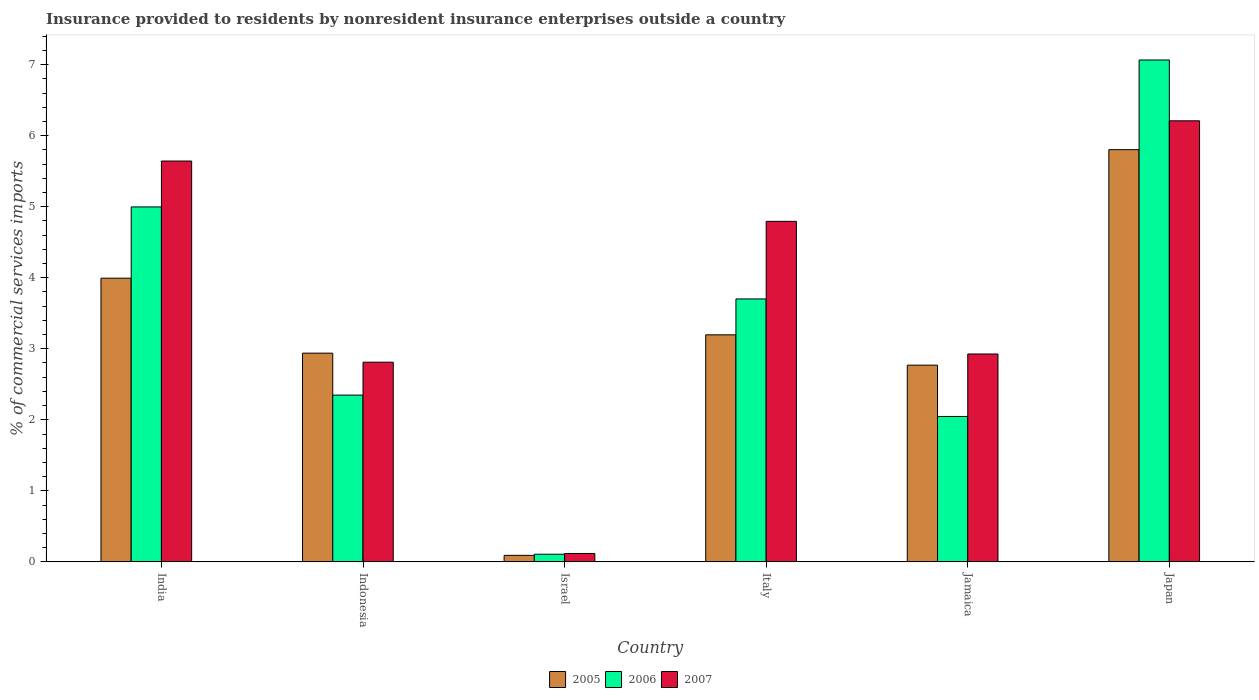How many groups of bars are there?
Keep it short and to the point. 6. How many bars are there on the 2nd tick from the right?
Provide a short and direct response. 3. What is the label of the 1st group of bars from the left?
Your answer should be very brief. India. What is the Insurance provided to residents in 2007 in Jamaica?
Offer a terse response. 2.93. Across all countries, what is the maximum Insurance provided to residents in 2005?
Keep it short and to the point. 5.8. Across all countries, what is the minimum Insurance provided to residents in 2007?
Offer a very short reply. 0.12. What is the total Insurance provided to residents in 2007 in the graph?
Your answer should be compact. 22.5. What is the difference between the Insurance provided to residents in 2007 in Indonesia and that in Jamaica?
Ensure brevity in your answer.  -0.12. What is the difference between the Insurance provided to residents in 2007 in Indonesia and the Insurance provided to residents in 2006 in India?
Offer a very short reply. -2.19. What is the average Insurance provided to residents in 2005 per country?
Provide a short and direct response. 3.13. What is the difference between the Insurance provided to residents of/in 2005 and Insurance provided to residents of/in 2006 in Italy?
Provide a succinct answer. -0.51. In how many countries, is the Insurance provided to residents in 2007 greater than 4.2 %?
Offer a terse response. 3. What is the ratio of the Insurance provided to residents in 2006 in Indonesia to that in Jamaica?
Provide a succinct answer. 1.15. Is the Insurance provided to residents in 2007 in Indonesia less than that in Italy?
Offer a terse response. Yes. What is the difference between the highest and the second highest Insurance provided to residents in 2006?
Your response must be concise. -1.3. What is the difference between the highest and the lowest Insurance provided to residents in 2006?
Your answer should be compact. 6.96. In how many countries, is the Insurance provided to residents in 2006 greater than the average Insurance provided to residents in 2006 taken over all countries?
Give a very brief answer. 3. Is the sum of the Insurance provided to residents in 2007 in Indonesia and Italy greater than the maximum Insurance provided to residents in 2006 across all countries?
Keep it short and to the point. Yes. Is it the case that in every country, the sum of the Insurance provided to residents in 2007 and Insurance provided to residents in 2006 is greater than the Insurance provided to residents in 2005?
Provide a short and direct response. Yes. How many countries are there in the graph?
Offer a terse response. 6. Are the values on the major ticks of Y-axis written in scientific E-notation?
Provide a short and direct response. No. Does the graph contain grids?
Your answer should be compact. No. Where does the legend appear in the graph?
Offer a very short reply. Bottom center. How many legend labels are there?
Give a very brief answer. 3. How are the legend labels stacked?
Provide a short and direct response. Horizontal. What is the title of the graph?
Your answer should be compact. Insurance provided to residents by nonresident insurance enterprises outside a country. What is the label or title of the Y-axis?
Ensure brevity in your answer.  % of commercial services imports. What is the % of commercial services imports in 2005 in India?
Keep it short and to the point. 3.99. What is the % of commercial services imports in 2006 in India?
Keep it short and to the point. 5. What is the % of commercial services imports of 2007 in India?
Offer a terse response. 5.64. What is the % of commercial services imports of 2005 in Indonesia?
Provide a short and direct response. 2.94. What is the % of commercial services imports in 2006 in Indonesia?
Keep it short and to the point. 2.35. What is the % of commercial services imports in 2007 in Indonesia?
Keep it short and to the point. 2.81. What is the % of commercial services imports of 2005 in Israel?
Offer a terse response. 0.09. What is the % of commercial services imports in 2006 in Israel?
Offer a very short reply. 0.11. What is the % of commercial services imports of 2007 in Israel?
Give a very brief answer. 0.12. What is the % of commercial services imports in 2005 in Italy?
Ensure brevity in your answer.  3.2. What is the % of commercial services imports in 2006 in Italy?
Provide a succinct answer. 3.7. What is the % of commercial services imports in 2007 in Italy?
Offer a terse response. 4.79. What is the % of commercial services imports in 2005 in Jamaica?
Your answer should be compact. 2.77. What is the % of commercial services imports of 2006 in Jamaica?
Your response must be concise. 2.05. What is the % of commercial services imports of 2007 in Jamaica?
Give a very brief answer. 2.93. What is the % of commercial services imports of 2005 in Japan?
Offer a very short reply. 5.8. What is the % of commercial services imports in 2006 in Japan?
Your answer should be very brief. 7.07. What is the % of commercial services imports of 2007 in Japan?
Keep it short and to the point. 6.21. Across all countries, what is the maximum % of commercial services imports in 2005?
Give a very brief answer. 5.8. Across all countries, what is the maximum % of commercial services imports of 2006?
Keep it short and to the point. 7.07. Across all countries, what is the maximum % of commercial services imports in 2007?
Your answer should be very brief. 6.21. Across all countries, what is the minimum % of commercial services imports of 2005?
Your answer should be very brief. 0.09. Across all countries, what is the minimum % of commercial services imports in 2006?
Provide a short and direct response. 0.11. Across all countries, what is the minimum % of commercial services imports in 2007?
Offer a very short reply. 0.12. What is the total % of commercial services imports in 2005 in the graph?
Offer a terse response. 18.79. What is the total % of commercial services imports in 2006 in the graph?
Make the answer very short. 20.27. What is the total % of commercial services imports in 2007 in the graph?
Keep it short and to the point. 22.5. What is the difference between the % of commercial services imports in 2005 in India and that in Indonesia?
Make the answer very short. 1.06. What is the difference between the % of commercial services imports of 2006 in India and that in Indonesia?
Give a very brief answer. 2.65. What is the difference between the % of commercial services imports of 2007 in India and that in Indonesia?
Your response must be concise. 2.83. What is the difference between the % of commercial services imports of 2005 in India and that in Israel?
Ensure brevity in your answer.  3.9. What is the difference between the % of commercial services imports in 2006 in India and that in Israel?
Provide a succinct answer. 4.89. What is the difference between the % of commercial services imports in 2007 in India and that in Israel?
Give a very brief answer. 5.53. What is the difference between the % of commercial services imports of 2005 in India and that in Italy?
Provide a succinct answer. 0.8. What is the difference between the % of commercial services imports in 2006 in India and that in Italy?
Your answer should be compact. 1.3. What is the difference between the % of commercial services imports in 2007 in India and that in Italy?
Provide a short and direct response. 0.85. What is the difference between the % of commercial services imports in 2005 in India and that in Jamaica?
Your answer should be compact. 1.22. What is the difference between the % of commercial services imports in 2006 in India and that in Jamaica?
Your answer should be very brief. 2.95. What is the difference between the % of commercial services imports in 2007 in India and that in Jamaica?
Offer a terse response. 2.72. What is the difference between the % of commercial services imports in 2005 in India and that in Japan?
Your answer should be compact. -1.81. What is the difference between the % of commercial services imports in 2006 in India and that in Japan?
Ensure brevity in your answer.  -2.07. What is the difference between the % of commercial services imports in 2007 in India and that in Japan?
Your answer should be very brief. -0.57. What is the difference between the % of commercial services imports of 2005 in Indonesia and that in Israel?
Provide a short and direct response. 2.85. What is the difference between the % of commercial services imports in 2006 in Indonesia and that in Israel?
Provide a short and direct response. 2.24. What is the difference between the % of commercial services imports in 2007 in Indonesia and that in Israel?
Offer a very short reply. 2.69. What is the difference between the % of commercial services imports of 2005 in Indonesia and that in Italy?
Give a very brief answer. -0.26. What is the difference between the % of commercial services imports in 2006 in Indonesia and that in Italy?
Offer a very short reply. -1.35. What is the difference between the % of commercial services imports in 2007 in Indonesia and that in Italy?
Provide a succinct answer. -1.98. What is the difference between the % of commercial services imports of 2005 in Indonesia and that in Jamaica?
Make the answer very short. 0.17. What is the difference between the % of commercial services imports in 2006 in Indonesia and that in Jamaica?
Offer a very short reply. 0.3. What is the difference between the % of commercial services imports in 2007 in Indonesia and that in Jamaica?
Provide a succinct answer. -0.12. What is the difference between the % of commercial services imports of 2005 in Indonesia and that in Japan?
Your answer should be compact. -2.87. What is the difference between the % of commercial services imports of 2006 in Indonesia and that in Japan?
Your answer should be compact. -4.72. What is the difference between the % of commercial services imports in 2007 in Indonesia and that in Japan?
Ensure brevity in your answer.  -3.4. What is the difference between the % of commercial services imports in 2005 in Israel and that in Italy?
Your answer should be very brief. -3.1. What is the difference between the % of commercial services imports of 2006 in Israel and that in Italy?
Make the answer very short. -3.59. What is the difference between the % of commercial services imports in 2007 in Israel and that in Italy?
Offer a very short reply. -4.68. What is the difference between the % of commercial services imports of 2005 in Israel and that in Jamaica?
Keep it short and to the point. -2.68. What is the difference between the % of commercial services imports of 2006 in Israel and that in Jamaica?
Provide a succinct answer. -1.94. What is the difference between the % of commercial services imports of 2007 in Israel and that in Jamaica?
Provide a short and direct response. -2.81. What is the difference between the % of commercial services imports in 2005 in Israel and that in Japan?
Your answer should be very brief. -5.71. What is the difference between the % of commercial services imports in 2006 in Israel and that in Japan?
Keep it short and to the point. -6.96. What is the difference between the % of commercial services imports in 2007 in Israel and that in Japan?
Offer a terse response. -6.09. What is the difference between the % of commercial services imports in 2005 in Italy and that in Jamaica?
Offer a very short reply. 0.43. What is the difference between the % of commercial services imports in 2006 in Italy and that in Jamaica?
Your response must be concise. 1.65. What is the difference between the % of commercial services imports of 2007 in Italy and that in Jamaica?
Ensure brevity in your answer.  1.87. What is the difference between the % of commercial services imports in 2005 in Italy and that in Japan?
Keep it short and to the point. -2.61. What is the difference between the % of commercial services imports in 2006 in Italy and that in Japan?
Provide a succinct answer. -3.36. What is the difference between the % of commercial services imports of 2007 in Italy and that in Japan?
Your answer should be compact. -1.42. What is the difference between the % of commercial services imports in 2005 in Jamaica and that in Japan?
Your response must be concise. -3.03. What is the difference between the % of commercial services imports in 2006 in Jamaica and that in Japan?
Your answer should be very brief. -5.02. What is the difference between the % of commercial services imports in 2007 in Jamaica and that in Japan?
Make the answer very short. -3.28. What is the difference between the % of commercial services imports of 2005 in India and the % of commercial services imports of 2006 in Indonesia?
Give a very brief answer. 1.65. What is the difference between the % of commercial services imports of 2005 in India and the % of commercial services imports of 2007 in Indonesia?
Provide a short and direct response. 1.18. What is the difference between the % of commercial services imports in 2006 in India and the % of commercial services imports in 2007 in Indonesia?
Offer a terse response. 2.19. What is the difference between the % of commercial services imports of 2005 in India and the % of commercial services imports of 2006 in Israel?
Your answer should be compact. 3.89. What is the difference between the % of commercial services imports of 2005 in India and the % of commercial services imports of 2007 in Israel?
Offer a very short reply. 3.88. What is the difference between the % of commercial services imports in 2006 in India and the % of commercial services imports in 2007 in Israel?
Your answer should be compact. 4.88. What is the difference between the % of commercial services imports in 2005 in India and the % of commercial services imports in 2006 in Italy?
Offer a terse response. 0.29. What is the difference between the % of commercial services imports in 2005 in India and the % of commercial services imports in 2007 in Italy?
Ensure brevity in your answer.  -0.8. What is the difference between the % of commercial services imports of 2006 in India and the % of commercial services imports of 2007 in Italy?
Ensure brevity in your answer.  0.2. What is the difference between the % of commercial services imports in 2005 in India and the % of commercial services imports in 2006 in Jamaica?
Your response must be concise. 1.95. What is the difference between the % of commercial services imports in 2005 in India and the % of commercial services imports in 2007 in Jamaica?
Make the answer very short. 1.07. What is the difference between the % of commercial services imports in 2006 in India and the % of commercial services imports in 2007 in Jamaica?
Offer a terse response. 2.07. What is the difference between the % of commercial services imports of 2005 in India and the % of commercial services imports of 2006 in Japan?
Provide a succinct answer. -3.07. What is the difference between the % of commercial services imports of 2005 in India and the % of commercial services imports of 2007 in Japan?
Offer a terse response. -2.22. What is the difference between the % of commercial services imports in 2006 in India and the % of commercial services imports in 2007 in Japan?
Your answer should be very brief. -1.21. What is the difference between the % of commercial services imports of 2005 in Indonesia and the % of commercial services imports of 2006 in Israel?
Give a very brief answer. 2.83. What is the difference between the % of commercial services imports in 2005 in Indonesia and the % of commercial services imports in 2007 in Israel?
Offer a terse response. 2.82. What is the difference between the % of commercial services imports of 2006 in Indonesia and the % of commercial services imports of 2007 in Israel?
Ensure brevity in your answer.  2.23. What is the difference between the % of commercial services imports in 2005 in Indonesia and the % of commercial services imports in 2006 in Italy?
Your answer should be compact. -0.76. What is the difference between the % of commercial services imports in 2005 in Indonesia and the % of commercial services imports in 2007 in Italy?
Your answer should be compact. -1.86. What is the difference between the % of commercial services imports of 2006 in Indonesia and the % of commercial services imports of 2007 in Italy?
Provide a short and direct response. -2.45. What is the difference between the % of commercial services imports in 2005 in Indonesia and the % of commercial services imports in 2006 in Jamaica?
Your response must be concise. 0.89. What is the difference between the % of commercial services imports in 2005 in Indonesia and the % of commercial services imports in 2007 in Jamaica?
Give a very brief answer. 0.01. What is the difference between the % of commercial services imports in 2006 in Indonesia and the % of commercial services imports in 2007 in Jamaica?
Ensure brevity in your answer.  -0.58. What is the difference between the % of commercial services imports of 2005 in Indonesia and the % of commercial services imports of 2006 in Japan?
Offer a terse response. -4.13. What is the difference between the % of commercial services imports in 2005 in Indonesia and the % of commercial services imports in 2007 in Japan?
Offer a very short reply. -3.27. What is the difference between the % of commercial services imports of 2006 in Indonesia and the % of commercial services imports of 2007 in Japan?
Provide a short and direct response. -3.86. What is the difference between the % of commercial services imports in 2005 in Israel and the % of commercial services imports in 2006 in Italy?
Offer a terse response. -3.61. What is the difference between the % of commercial services imports of 2005 in Israel and the % of commercial services imports of 2007 in Italy?
Provide a succinct answer. -4.7. What is the difference between the % of commercial services imports in 2006 in Israel and the % of commercial services imports in 2007 in Italy?
Offer a terse response. -4.69. What is the difference between the % of commercial services imports of 2005 in Israel and the % of commercial services imports of 2006 in Jamaica?
Provide a short and direct response. -1.96. What is the difference between the % of commercial services imports of 2005 in Israel and the % of commercial services imports of 2007 in Jamaica?
Offer a terse response. -2.83. What is the difference between the % of commercial services imports in 2006 in Israel and the % of commercial services imports in 2007 in Jamaica?
Offer a terse response. -2.82. What is the difference between the % of commercial services imports of 2005 in Israel and the % of commercial services imports of 2006 in Japan?
Offer a very short reply. -6.97. What is the difference between the % of commercial services imports of 2005 in Israel and the % of commercial services imports of 2007 in Japan?
Your answer should be compact. -6.12. What is the difference between the % of commercial services imports of 2006 in Israel and the % of commercial services imports of 2007 in Japan?
Offer a terse response. -6.1. What is the difference between the % of commercial services imports of 2005 in Italy and the % of commercial services imports of 2006 in Jamaica?
Ensure brevity in your answer.  1.15. What is the difference between the % of commercial services imports of 2005 in Italy and the % of commercial services imports of 2007 in Jamaica?
Your answer should be compact. 0.27. What is the difference between the % of commercial services imports in 2006 in Italy and the % of commercial services imports in 2007 in Jamaica?
Give a very brief answer. 0.78. What is the difference between the % of commercial services imports of 2005 in Italy and the % of commercial services imports of 2006 in Japan?
Provide a succinct answer. -3.87. What is the difference between the % of commercial services imports in 2005 in Italy and the % of commercial services imports in 2007 in Japan?
Make the answer very short. -3.01. What is the difference between the % of commercial services imports in 2006 in Italy and the % of commercial services imports in 2007 in Japan?
Your answer should be compact. -2.51. What is the difference between the % of commercial services imports of 2005 in Jamaica and the % of commercial services imports of 2006 in Japan?
Provide a short and direct response. -4.3. What is the difference between the % of commercial services imports of 2005 in Jamaica and the % of commercial services imports of 2007 in Japan?
Give a very brief answer. -3.44. What is the difference between the % of commercial services imports of 2006 in Jamaica and the % of commercial services imports of 2007 in Japan?
Give a very brief answer. -4.16. What is the average % of commercial services imports of 2005 per country?
Your answer should be compact. 3.13. What is the average % of commercial services imports of 2006 per country?
Offer a terse response. 3.38. What is the average % of commercial services imports in 2007 per country?
Make the answer very short. 3.75. What is the difference between the % of commercial services imports in 2005 and % of commercial services imports in 2006 in India?
Your answer should be compact. -1. What is the difference between the % of commercial services imports in 2005 and % of commercial services imports in 2007 in India?
Keep it short and to the point. -1.65. What is the difference between the % of commercial services imports in 2006 and % of commercial services imports in 2007 in India?
Provide a succinct answer. -0.65. What is the difference between the % of commercial services imports of 2005 and % of commercial services imports of 2006 in Indonesia?
Ensure brevity in your answer.  0.59. What is the difference between the % of commercial services imports of 2005 and % of commercial services imports of 2007 in Indonesia?
Your answer should be compact. 0.13. What is the difference between the % of commercial services imports of 2006 and % of commercial services imports of 2007 in Indonesia?
Provide a succinct answer. -0.46. What is the difference between the % of commercial services imports in 2005 and % of commercial services imports in 2006 in Israel?
Offer a very short reply. -0.02. What is the difference between the % of commercial services imports of 2005 and % of commercial services imports of 2007 in Israel?
Keep it short and to the point. -0.03. What is the difference between the % of commercial services imports of 2006 and % of commercial services imports of 2007 in Israel?
Offer a very short reply. -0.01. What is the difference between the % of commercial services imports in 2005 and % of commercial services imports in 2006 in Italy?
Provide a succinct answer. -0.51. What is the difference between the % of commercial services imports in 2005 and % of commercial services imports in 2007 in Italy?
Make the answer very short. -1.6. What is the difference between the % of commercial services imports in 2006 and % of commercial services imports in 2007 in Italy?
Make the answer very short. -1.09. What is the difference between the % of commercial services imports in 2005 and % of commercial services imports in 2006 in Jamaica?
Your answer should be very brief. 0.72. What is the difference between the % of commercial services imports in 2005 and % of commercial services imports in 2007 in Jamaica?
Give a very brief answer. -0.16. What is the difference between the % of commercial services imports in 2006 and % of commercial services imports in 2007 in Jamaica?
Provide a short and direct response. -0.88. What is the difference between the % of commercial services imports of 2005 and % of commercial services imports of 2006 in Japan?
Make the answer very short. -1.26. What is the difference between the % of commercial services imports in 2005 and % of commercial services imports in 2007 in Japan?
Provide a short and direct response. -0.41. What is the difference between the % of commercial services imports of 2006 and % of commercial services imports of 2007 in Japan?
Your answer should be compact. 0.86. What is the ratio of the % of commercial services imports of 2005 in India to that in Indonesia?
Your response must be concise. 1.36. What is the ratio of the % of commercial services imports in 2006 in India to that in Indonesia?
Provide a succinct answer. 2.13. What is the ratio of the % of commercial services imports in 2007 in India to that in Indonesia?
Make the answer very short. 2.01. What is the ratio of the % of commercial services imports in 2005 in India to that in Israel?
Offer a terse response. 43.48. What is the ratio of the % of commercial services imports in 2006 in India to that in Israel?
Your answer should be compact. 46.46. What is the ratio of the % of commercial services imports of 2007 in India to that in Israel?
Keep it short and to the point. 47.74. What is the ratio of the % of commercial services imports in 2005 in India to that in Italy?
Your answer should be very brief. 1.25. What is the ratio of the % of commercial services imports of 2006 in India to that in Italy?
Your response must be concise. 1.35. What is the ratio of the % of commercial services imports of 2007 in India to that in Italy?
Your answer should be very brief. 1.18. What is the ratio of the % of commercial services imports in 2005 in India to that in Jamaica?
Ensure brevity in your answer.  1.44. What is the ratio of the % of commercial services imports of 2006 in India to that in Jamaica?
Make the answer very short. 2.44. What is the ratio of the % of commercial services imports in 2007 in India to that in Jamaica?
Your answer should be compact. 1.93. What is the ratio of the % of commercial services imports in 2005 in India to that in Japan?
Provide a short and direct response. 0.69. What is the ratio of the % of commercial services imports in 2006 in India to that in Japan?
Ensure brevity in your answer.  0.71. What is the ratio of the % of commercial services imports in 2007 in India to that in Japan?
Your answer should be compact. 0.91. What is the ratio of the % of commercial services imports of 2005 in Indonesia to that in Israel?
Ensure brevity in your answer.  31.99. What is the ratio of the % of commercial services imports in 2006 in Indonesia to that in Israel?
Your response must be concise. 21.83. What is the ratio of the % of commercial services imports of 2007 in Indonesia to that in Israel?
Offer a terse response. 23.78. What is the ratio of the % of commercial services imports of 2005 in Indonesia to that in Italy?
Your answer should be compact. 0.92. What is the ratio of the % of commercial services imports in 2006 in Indonesia to that in Italy?
Your answer should be very brief. 0.63. What is the ratio of the % of commercial services imports in 2007 in Indonesia to that in Italy?
Provide a short and direct response. 0.59. What is the ratio of the % of commercial services imports of 2005 in Indonesia to that in Jamaica?
Provide a succinct answer. 1.06. What is the ratio of the % of commercial services imports of 2006 in Indonesia to that in Jamaica?
Keep it short and to the point. 1.15. What is the ratio of the % of commercial services imports of 2007 in Indonesia to that in Jamaica?
Offer a very short reply. 0.96. What is the ratio of the % of commercial services imports of 2005 in Indonesia to that in Japan?
Provide a short and direct response. 0.51. What is the ratio of the % of commercial services imports in 2006 in Indonesia to that in Japan?
Ensure brevity in your answer.  0.33. What is the ratio of the % of commercial services imports in 2007 in Indonesia to that in Japan?
Your response must be concise. 0.45. What is the ratio of the % of commercial services imports in 2005 in Israel to that in Italy?
Your answer should be compact. 0.03. What is the ratio of the % of commercial services imports in 2006 in Israel to that in Italy?
Keep it short and to the point. 0.03. What is the ratio of the % of commercial services imports in 2007 in Israel to that in Italy?
Provide a succinct answer. 0.02. What is the ratio of the % of commercial services imports in 2005 in Israel to that in Jamaica?
Your answer should be very brief. 0.03. What is the ratio of the % of commercial services imports in 2006 in Israel to that in Jamaica?
Provide a short and direct response. 0.05. What is the ratio of the % of commercial services imports of 2007 in Israel to that in Jamaica?
Offer a terse response. 0.04. What is the ratio of the % of commercial services imports in 2005 in Israel to that in Japan?
Your response must be concise. 0.02. What is the ratio of the % of commercial services imports in 2006 in Israel to that in Japan?
Provide a short and direct response. 0.02. What is the ratio of the % of commercial services imports of 2007 in Israel to that in Japan?
Your response must be concise. 0.02. What is the ratio of the % of commercial services imports in 2005 in Italy to that in Jamaica?
Your response must be concise. 1.15. What is the ratio of the % of commercial services imports in 2006 in Italy to that in Jamaica?
Your answer should be compact. 1.81. What is the ratio of the % of commercial services imports in 2007 in Italy to that in Jamaica?
Ensure brevity in your answer.  1.64. What is the ratio of the % of commercial services imports in 2005 in Italy to that in Japan?
Provide a succinct answer. 0.55. What is the ratio of the % of commercial services imports in 2006 in Italy to that in Japan?
Give a very brief answer. 0.52. What is the ratio of the % of commercial services imports of 2007 in Italy to that in Japan?
Keep it short and to the point. 0.77. What is the ratio of the % of commercial services imports of 2005 in Jamaica to that in Japan?
Keep it short and to the point. 0.48. What is the ratio of the % of commercial services imports of 2006 in Jamaica to that in Japan?
Provide a short and direct response. 0.29. What is the ratio of the % of commercial services imports in 2007 in Jamaica to that in Japan?
Give a very brief answer. 0.47. What is the difference between the highest and the second highest % of commercial services imports of 2005?
Provide a short and direct response. 1.81. What is the difference between the highest and the second highest % of commercial services imports of 2006?
Keep it short and to the point. 2.07. What is the difference between the highest and the second highest % of commercial services imports of 2007?
Offer a terse response. 0.57. What is the difference between the highest and the lowest % of commercial services imports in 2005?
Provide a short and direct response. 5.71. What is the difference between the highest and the lowest % of commercial services imports in 2006?
Your response must be concise. 6.96. What is the difference between the highest and the lowest % of commercial services imports of 2007?
Your answer should be very brief. 6.09. 